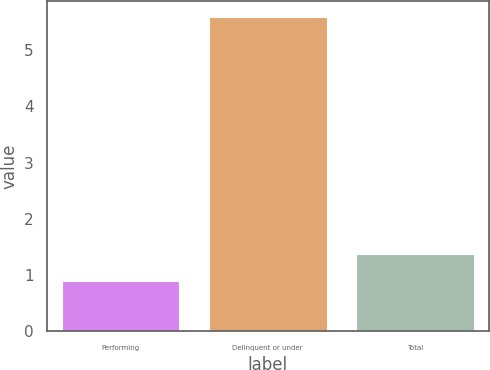Convert chart. <chart><loc_0><loc_0><loc_500><loc_500><bar_chart><fcel>Performing<fcel>Delinquent or under<fcel>Total<nl><fcel>0.9<fcel>5.6<fcel>1.37<nl></chart> 